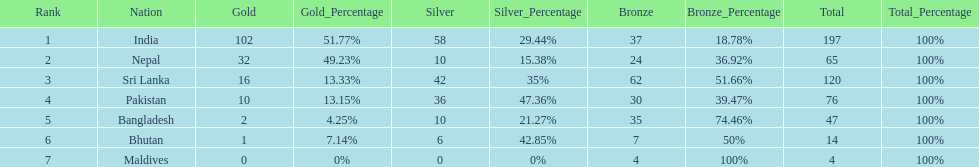Which nation has earned the least amount of gold medals? Maldives. 